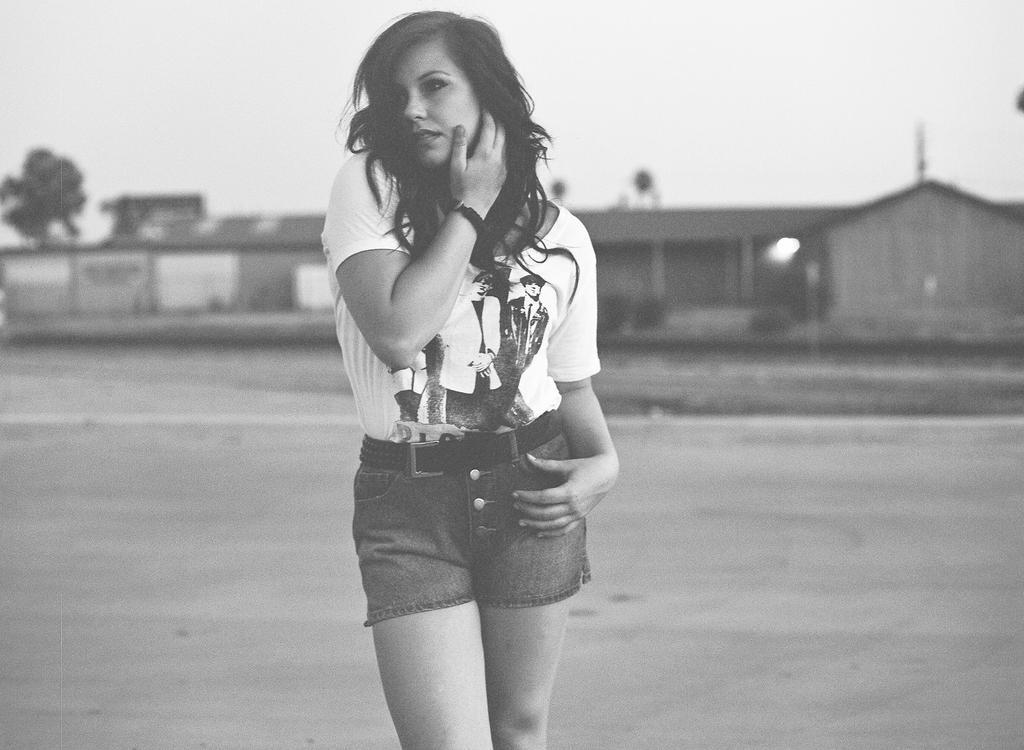In one or two sentences, can you explain what this image depicts? This is a black and white picture. Here we can see a woman. In the background we can see a house, trees, and sky. 